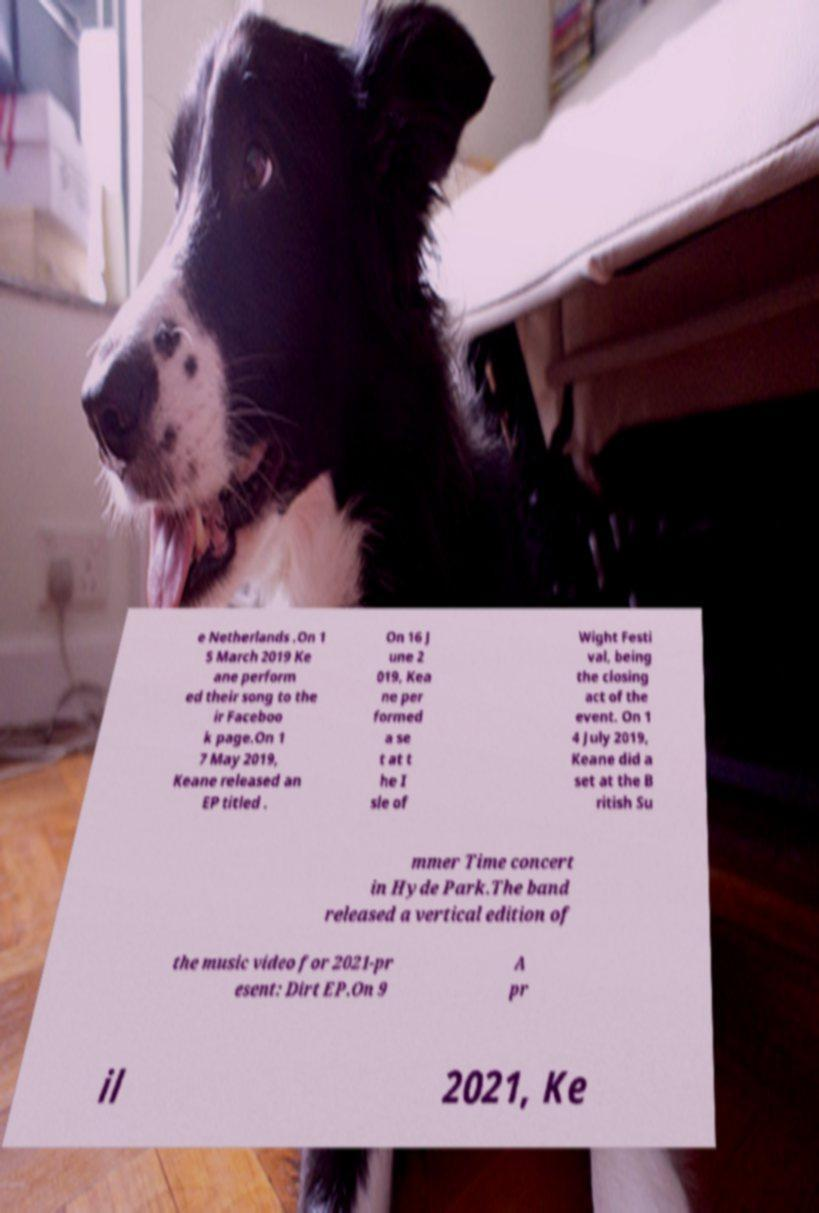Can you accurately transcribe the text from the provided image for me? e Netherlands .On 1 5 March 2019 Ke ane perform ed their song to the ir Faceboo k page.On 1 7 May 2019, Keane released an EP titled . On 16 J une 2 019, Kea ne per formed a se t at t he I sle of Wight Festi val, being the closing act of the event. On 1 4 July 2019, Keane did a set at the B ritish Su mmer Time concert in Hyde Park.The band released a vertical edition of the music video for 2021-pr esent: Dirt EP.On 9 A pr il 2021, Ke 